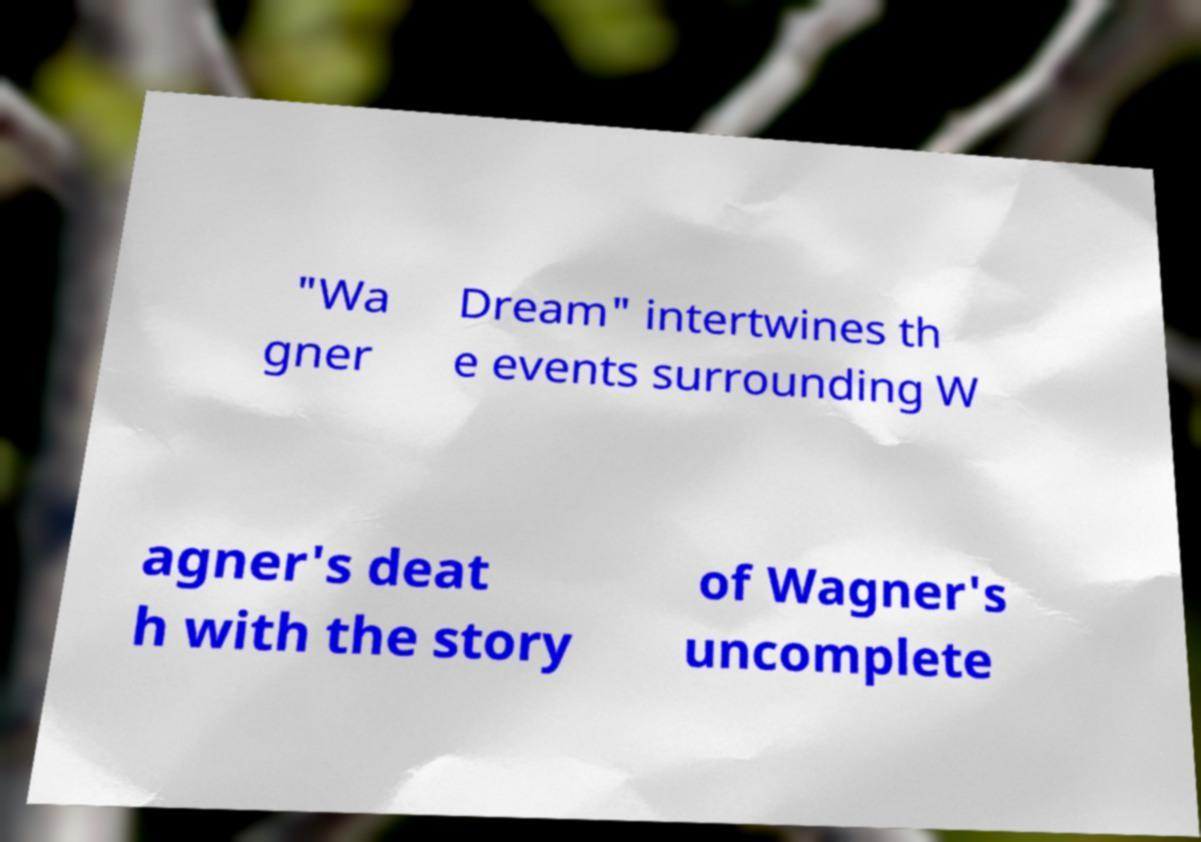Could you assist in decoding the text presented in this image and type it out clearly? "Wa gner Dream" intertwines th e events surrounding W agner's deat h with the story of Wagner's uncomplete 